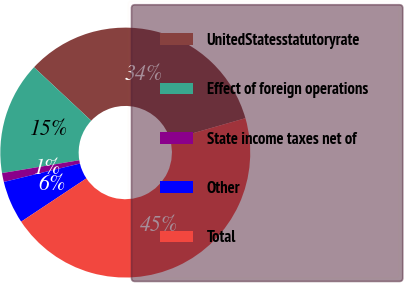<chart> <loc_0><loc_0><loc_500><loc_500><pie_chart><fcel>UnitedStatesstatutoryrate<fcel>Effect of foreign operations<fcel>State income taxes net of<fcel>Other<fcel>Total<nl><fcel>33.6%<fcel>14.59%<fcel>1.15%<fcel>5.55%<fcel>45.11%<nl></chart> 